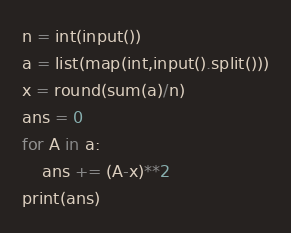<code> <loc_0><loc_0><loc_500><loc_500><_Python_>n = int(input())
a = list(map(int,input().split()))
x = round(sum(a)/n)
ans = 0
for A in a:
    ans += (A-x)**2
print(ans)</code> 